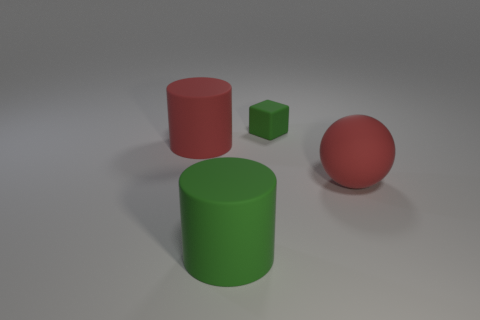Add 1 red cylinders. How many objects exist? 5 Subtract all cubes. How many objects are left? 3 Add 3 small green matte blocks. How many small green matte blocks exist? 4 Subtract 1 red cylinders. How many objects are left? 3 Subtract all big red metallic spheres. Subtract all green rubber cubes. How many objects are left? 3 Add 2 large green things. How many large green things are left? 3 